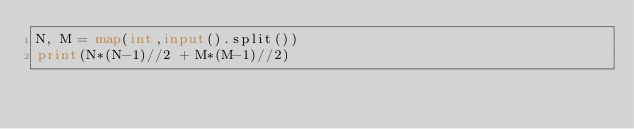<code> <loc_0><loc_0><loc_500><loc_500><_Python_>N, M = map(int,input().split())
print(N*(N-1)//2 + M*(M-1)//2)</code> 